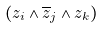Convert formula to latex. <formula><loc_0><loc_0><loc_500><loc_500>( z _ { i } \wedge \overline { z } _ { j } \wedge z _ { k } )</formula> 